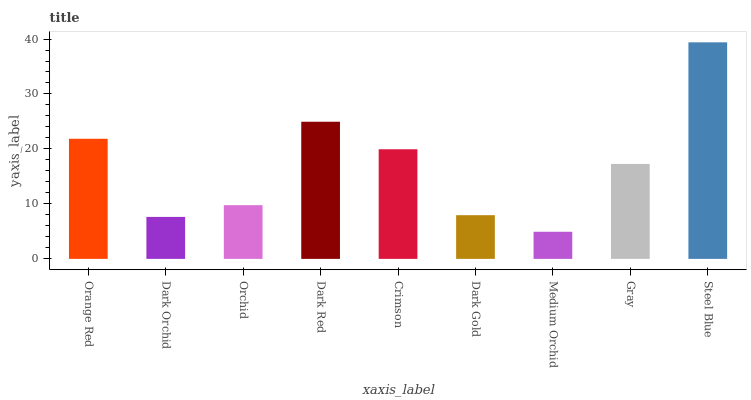Is Medium Orchid the minimum?
Answer yes or no. Yes. Is Steel Blue the maximum?
Answer yes or no. Yes. Is Dark Orchid the minimum?
Answer yes or no. No. Is Dark Orchid the maximum?
Answer yes or no. No. Is Orange Red greater than Dark Orchid?
Answer yes or no. Yes. Is Dark Orchid less than Orange Red?
Answer yes or no. Yes. Is Dark Orchid greater than Orange Red?
Answer yes or no. No. Is Orange Red less than Dark Orchid?
Answer yes or no. No. Is Gray the high median?
Answer yes or no. Yes. Is Gray the low median?
Answer yes or no. Yes. Is Dark Orchid the high median?
Answer yes or no. No. Is Dark Gold the low median?
Answer yes or no. No. 